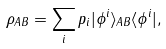Convert formula to latex. <formula><loc_0><loc_0><loc_500><loc_500>\rho _ { A B } = \sum _ { i } p _ { i } | \phi ^ { i } \rangle _ { A B } \langle \phi ^ { i } | ,</formula> 